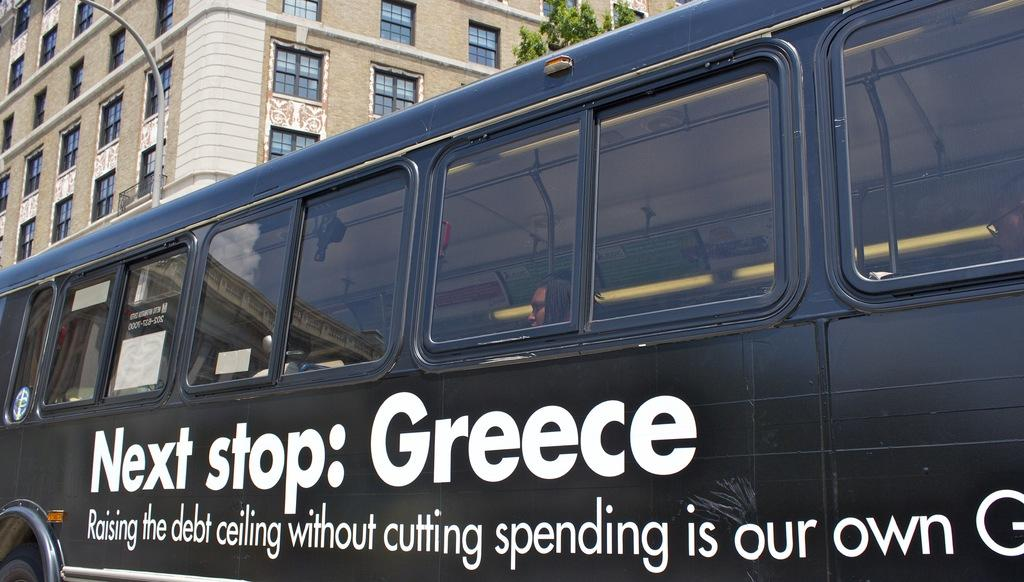What color is the bus in the image? The bus in the image is black. What can be seen written on the bus? There are white color words painted on the bus. What is visible in the background of the image? There is a cream color building and a tree in the background of the image. Where is the pen located in the image? There is no pen present in the image. What type of kettle can be seen in the background of the image? There is no kettle present in the image. 